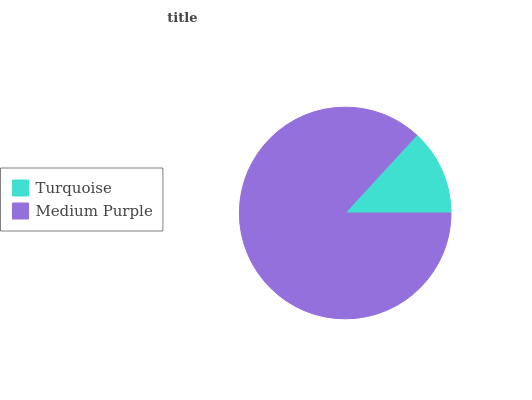Is Turquoise the minimum?
Answer yes or no. Yes. Is Medium Purple the maximum?
Answer yes or no. Yes. Is Medium Purple the minimum?
Answer yes or no. No. Is Medium Purple greater than Turquoise?
Answer yes or no. Yes. Is Turquoise less than Medium Purple?
Answer yes or no. Yes. Is Turquoise greater than Medium Purple?
Answer yes or no. No. Is Medium Purple less than Turquoise?
Answer yes or no. No. Is Medium Purple the high median?
Answer yes or no. Yes. Is Turquoise the low median?
Answer yes or no. Yes. Is Turquoise the high median?
Answer yes or no. No. Is Medium Purple the low median?
Answer yes or no. No. 